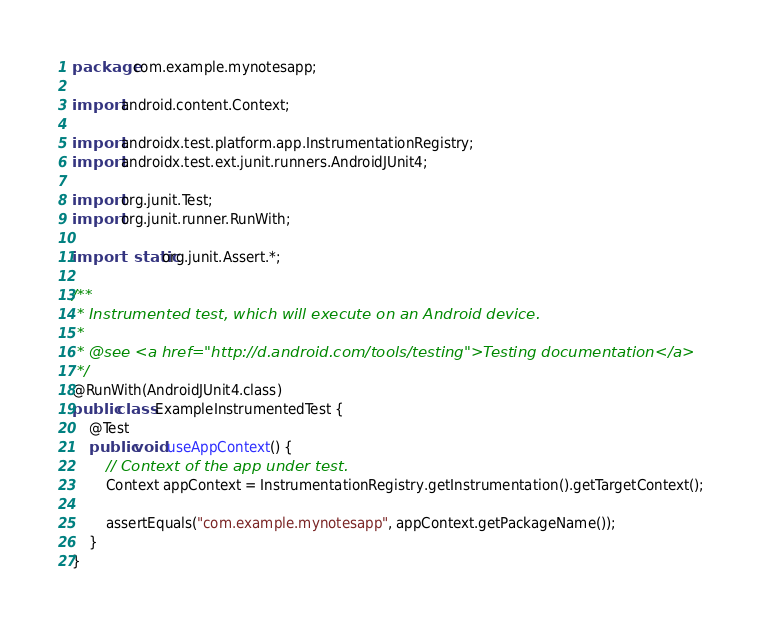<code> <loc_0><loc_0><loc_500><loc_500><_Java_>package com.example.mynotesapp;

import android.content.Context;

import androidx.test.platform.app.InstrumentationRegistry;
import androidx.test.ext.junit.runners.AndroidJUnit4;

import org.junit.Test;
import org.junit.runner.RunWith;

import static org.junit.Assert.*;

/**
 * Instrumented test, which will execute on an Android device.
 *
 * @see <a href="http://d.android.com/tools/testing">Testing documentation</a>
 */
@RunWith(AndroidJUnit4.class)
public class ExampleInstrumentedTest {
    @Test
    public void useAppContext() {
        // Context of the app under test.
        Context appContext = InstrumentationRegistry.getInstrumentation().getTargetContext();

        assertEquals("com.example.mynotesapp", appContext.getPackageName());
    }
}
</code> 